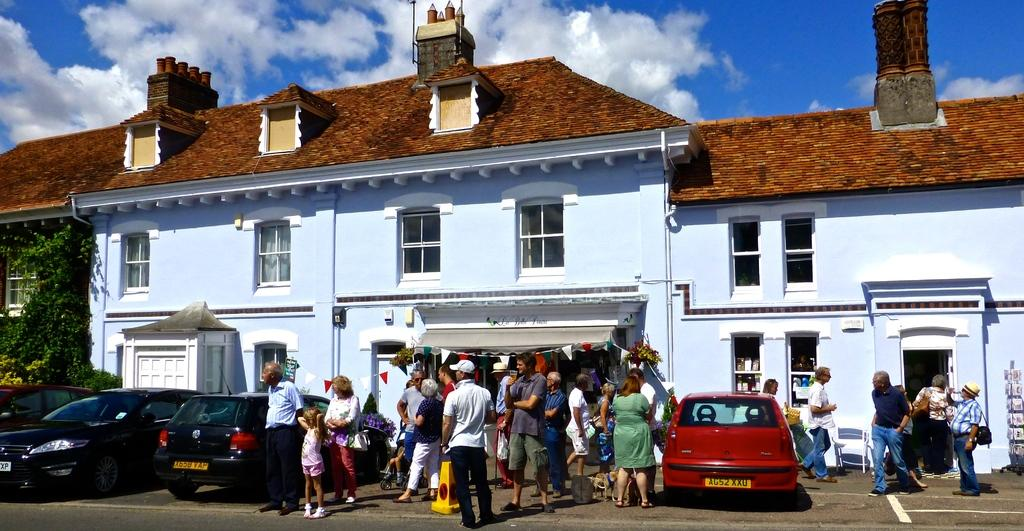What is happening in the image? There is a group of people standing in the image. Can you describe the setting of the image? There is a house in the image. What is the weather like in the image? The sky is slightly cloudy and blue in the image. How many leaves are on the hill in the image? There is no hill or leaves present in the image. 